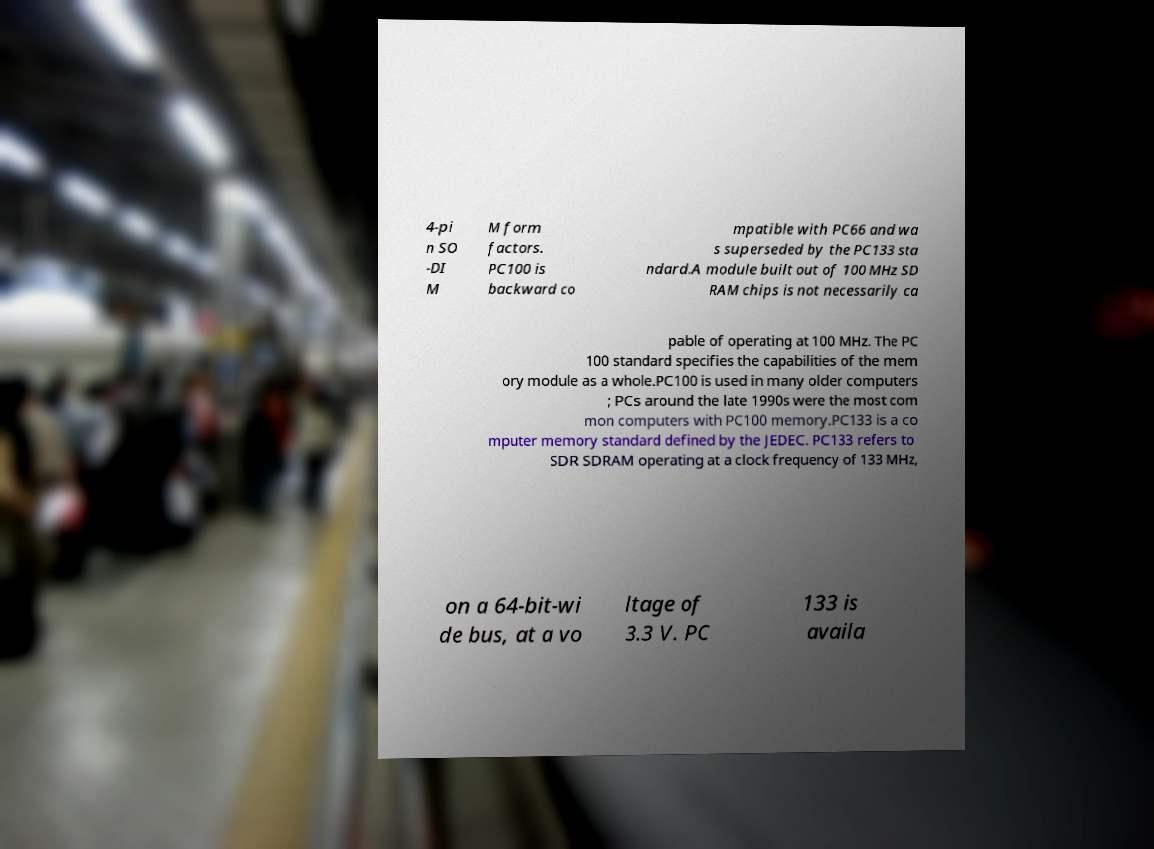Can you read and provide the text displayed in the image?This photo seems to have some interesting text. Can you extract and type it out for me? 4-pi n SO -DI M M form factors. PC100 is backward co mpatible with PC66 and wa s superseded by the PC133 sta ndard.A module built out of 100 MHz SD RAM chips is not necessarily ca pable of operating at 100 MHz. The PC 100 standard specifies the capabilities of the mem ory module as a whole.PC100 is used in many older computers ; PCs around the late 1990s were the most com mon computers with PC100 memory.PC133 is a co mputer memory standard defined by the JEDEC. PC133 refers to SDR SDRAM operating at a clock frequency of 133 MHz, on a 64-bit-wi de bus, at a vo ltage of 3.3 V. PC 133 is availa 